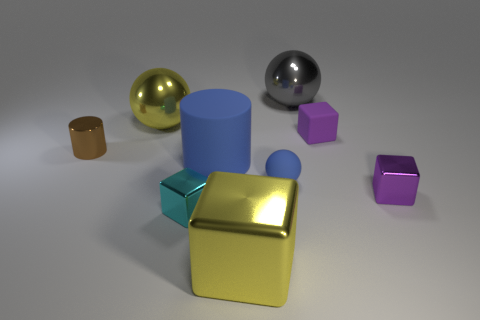What material is the object that is the same color as the small rubber cube?
Provide a short and direct response. Metal. What number of shiny cubes are the same color as the matte cylinder?
Your answer should be compact. 0. What is the yellow object that is in front of the big yellow object that is left of the big yellow metallic object in front of the cyan thing made of?
Offer a terse response. Metal. What is the color of the tiny shiny block to the left of the yellow metallic thing that is in front of the blue matte cylinder?
Make the answer very short. Cyan. How many small things are either brown cubes or blue rubber balls?
Your response must be concise. 1. How many large gray spheres have the same material as the big yellow sphere?
Make the answer very short. 1. There is a yellow thing in front of the big rubber thing; what size is it?
Provide a short and direct response. Large. What shape is the yellow object behind the tiny purple thing behind the tiny brown shiny cylinder?
Your response must be concise. Sphere. How many small purple blocks are left of the large blue matte cylinder in front of the small matte thing to the right of the big gray metallic ball?
Ensure brevity in your answer.  0. Are there fewer brown objects in front of the brown thing than yellow objects?
Make the answer very short. Yes. 